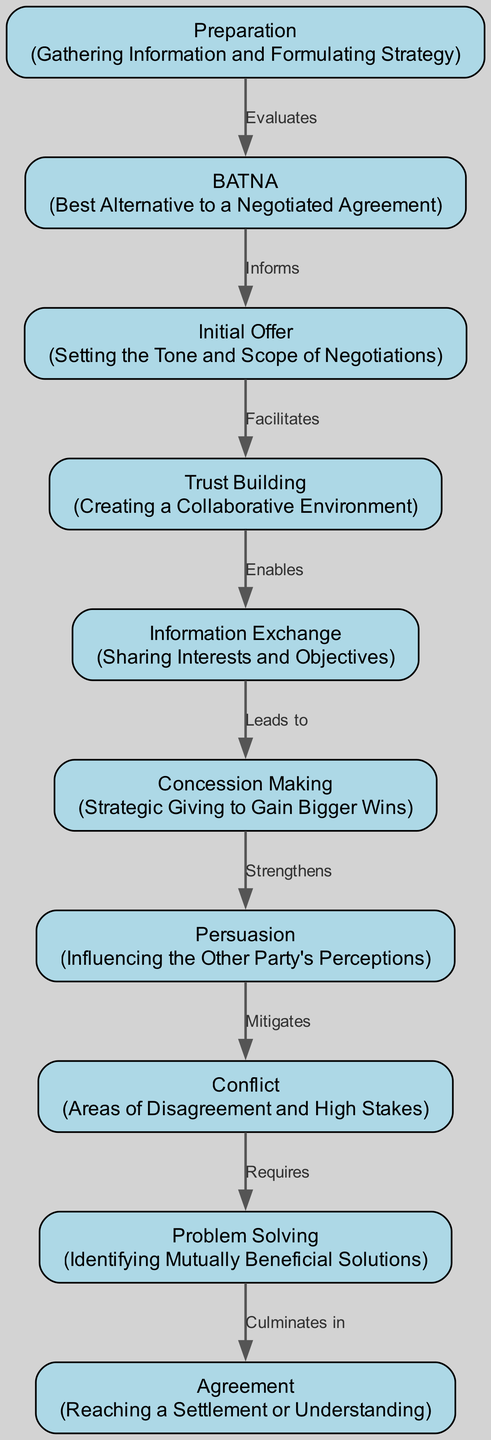What is the first node in the diagram? The first node listed in the diagram is "Preparation," which is the starting point for other processes in conflict resolution.
Answer: Preparation How many nodes are present in the diagram? By counting the nodes listed in the data, we find there are 10 distinct nodes represented.
Answer: 10 What relationship exists between "Information Exchange" and "Concession Making"? In the diagram, the relationship is indicated as "Leads to," showing that Information Exchange is a precursor to making concessions.
Answer: Leads to Which node culminates in "Agreement"? The node that leads directly to "Agreement" is "Problem Solving," which indicates that identifying mutually beneficial solutions leads to reaching a settlement or understanding.
Answer: Problem Solving What is described as "Creating a Collaborative Environment"? The node described as "Creating a Collaborative Environment" is "Trust Building," highlighting its importance in the negotiation process.
Answer: Trust Building What relationship does "Trust Building" have with "Information Exchange"? The relationship indicated in the diagram is "Enables," meaning that Trust Building facilitates the process of exchanging information between parties.
Answer: Enables If "Conflict" requires "Problem Solving," what does "Problem Solving" culminate in? Following the flow of the diagram, since Conflict requires Problem Solving, and Problem Solving culminates in Agreement, we can conclude that resolving problems leads to reaching an agreement.
Answer: Agreement What does "Concession Making" strengthen? The diagram states that Concession Making strengthens "Persuasion," indicating a connection where giving up something can enhance one's ability to convince the other party.
Answer: Persuasion Which node informs "Initial Offer"? The node that informs "Initial Offer" is "BATNA," as it provides essential information to formulate the initial negotiation offer.
Answer: BATNA What is the primary focus of the node labeled "8"? The primary focus of the node labeled "8" is "Conflict," which specifies the areas of disagreement and the stakes involved in negotiations.
Answer: Conflict 